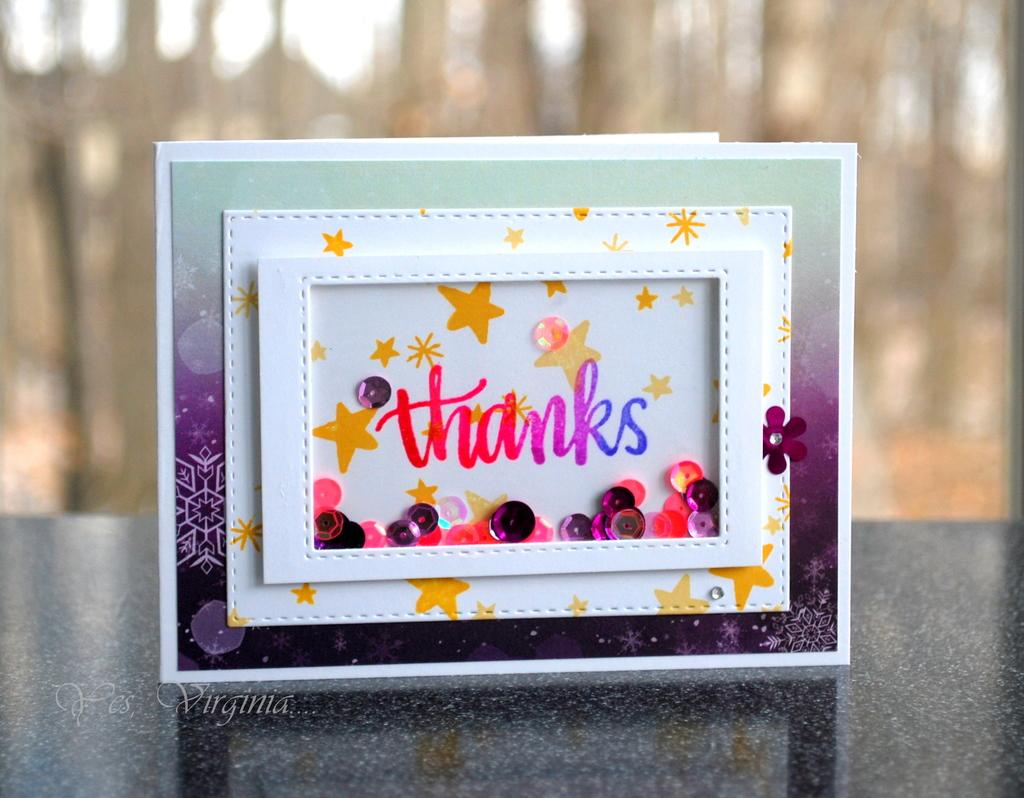What objects are present in the image? There are boards in the image. What is written or depicted on the boards? There is text on the boards. What type of card can be seen being used for digestion in the image? There is no card or reference to digestion present in the image; it only features boards with text. 